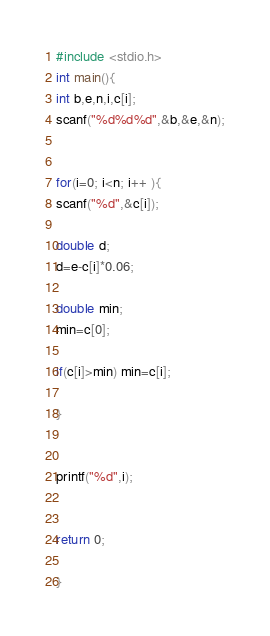<code> <loc_0><loc_0><loc_500><loc_500><_C_>#include <stdio.h>
int main(){
int b,e,n,i,c[i];
scanf("%d%d%d",&b,&e,&n);


for(i=0; i<n; i++ ){
scanf("%d",&c[i]);

double d;
d=e-c[i]*0.06;

double min;
min=c[0];

if(c[i]>min) min=c[i];

}


printf("%d",i);


return 0;

}</code> 